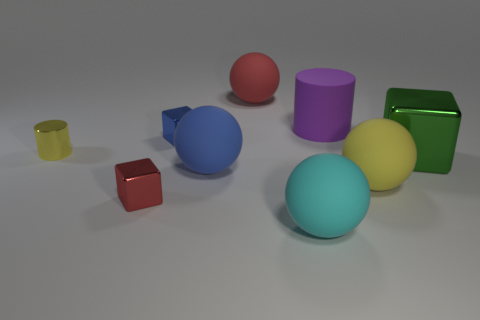Is there a object that has the same color as the tiny cylinder?
Provide a succinct answer. Yes. Do the tiny metallic cylinder and the rubber ball that is right of the cyan ball have the same color?
Make the answer very short. Yes. How many big objects are rubber objects or green objects?
Provide a succinct answer. 6. What shape is the yellow thing that is made of the same material as the big green cube?
Make the answer very short. Cylinder. Is the green metallic object the same shape as the tiny blue shiny thing?
Make the answer very short. Yes. The large matte cylinder is what color?
Give a very brief answer. Purple. What number of things are either large green matte balls or cylinders?
Provide a succinct answer. 2. Is there any other thing that is the same material as the large blue ball?
Your answer should be very brief. Yes. Is the number of big cyan spheres in front of the large cyan rubber thing less than the number of big purple rubber cylinders?
Keep it short and to the point. Yes. Is the number of purple objects in front of the big rubber cylinder greater than the number of small yellow shiny objects that are in front of the cyan thing?
Provide a succinct answer. No. 